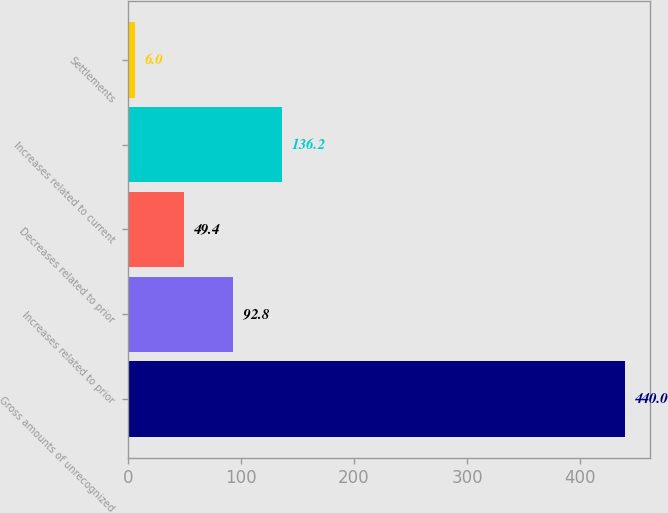<chart> <loc_0><loc_0><loc_500><loc_500><bar_chart><fcel>Gross amounts of unrecognized<fcel>Increases related to prior<fcel>Decreases related to prior<fcel>Increases related to current<fcel>Settlements<nl><fcel>440<fcel>92.8<fcel>49.4<fcel>136.2<fcel>6<nl></chart> 